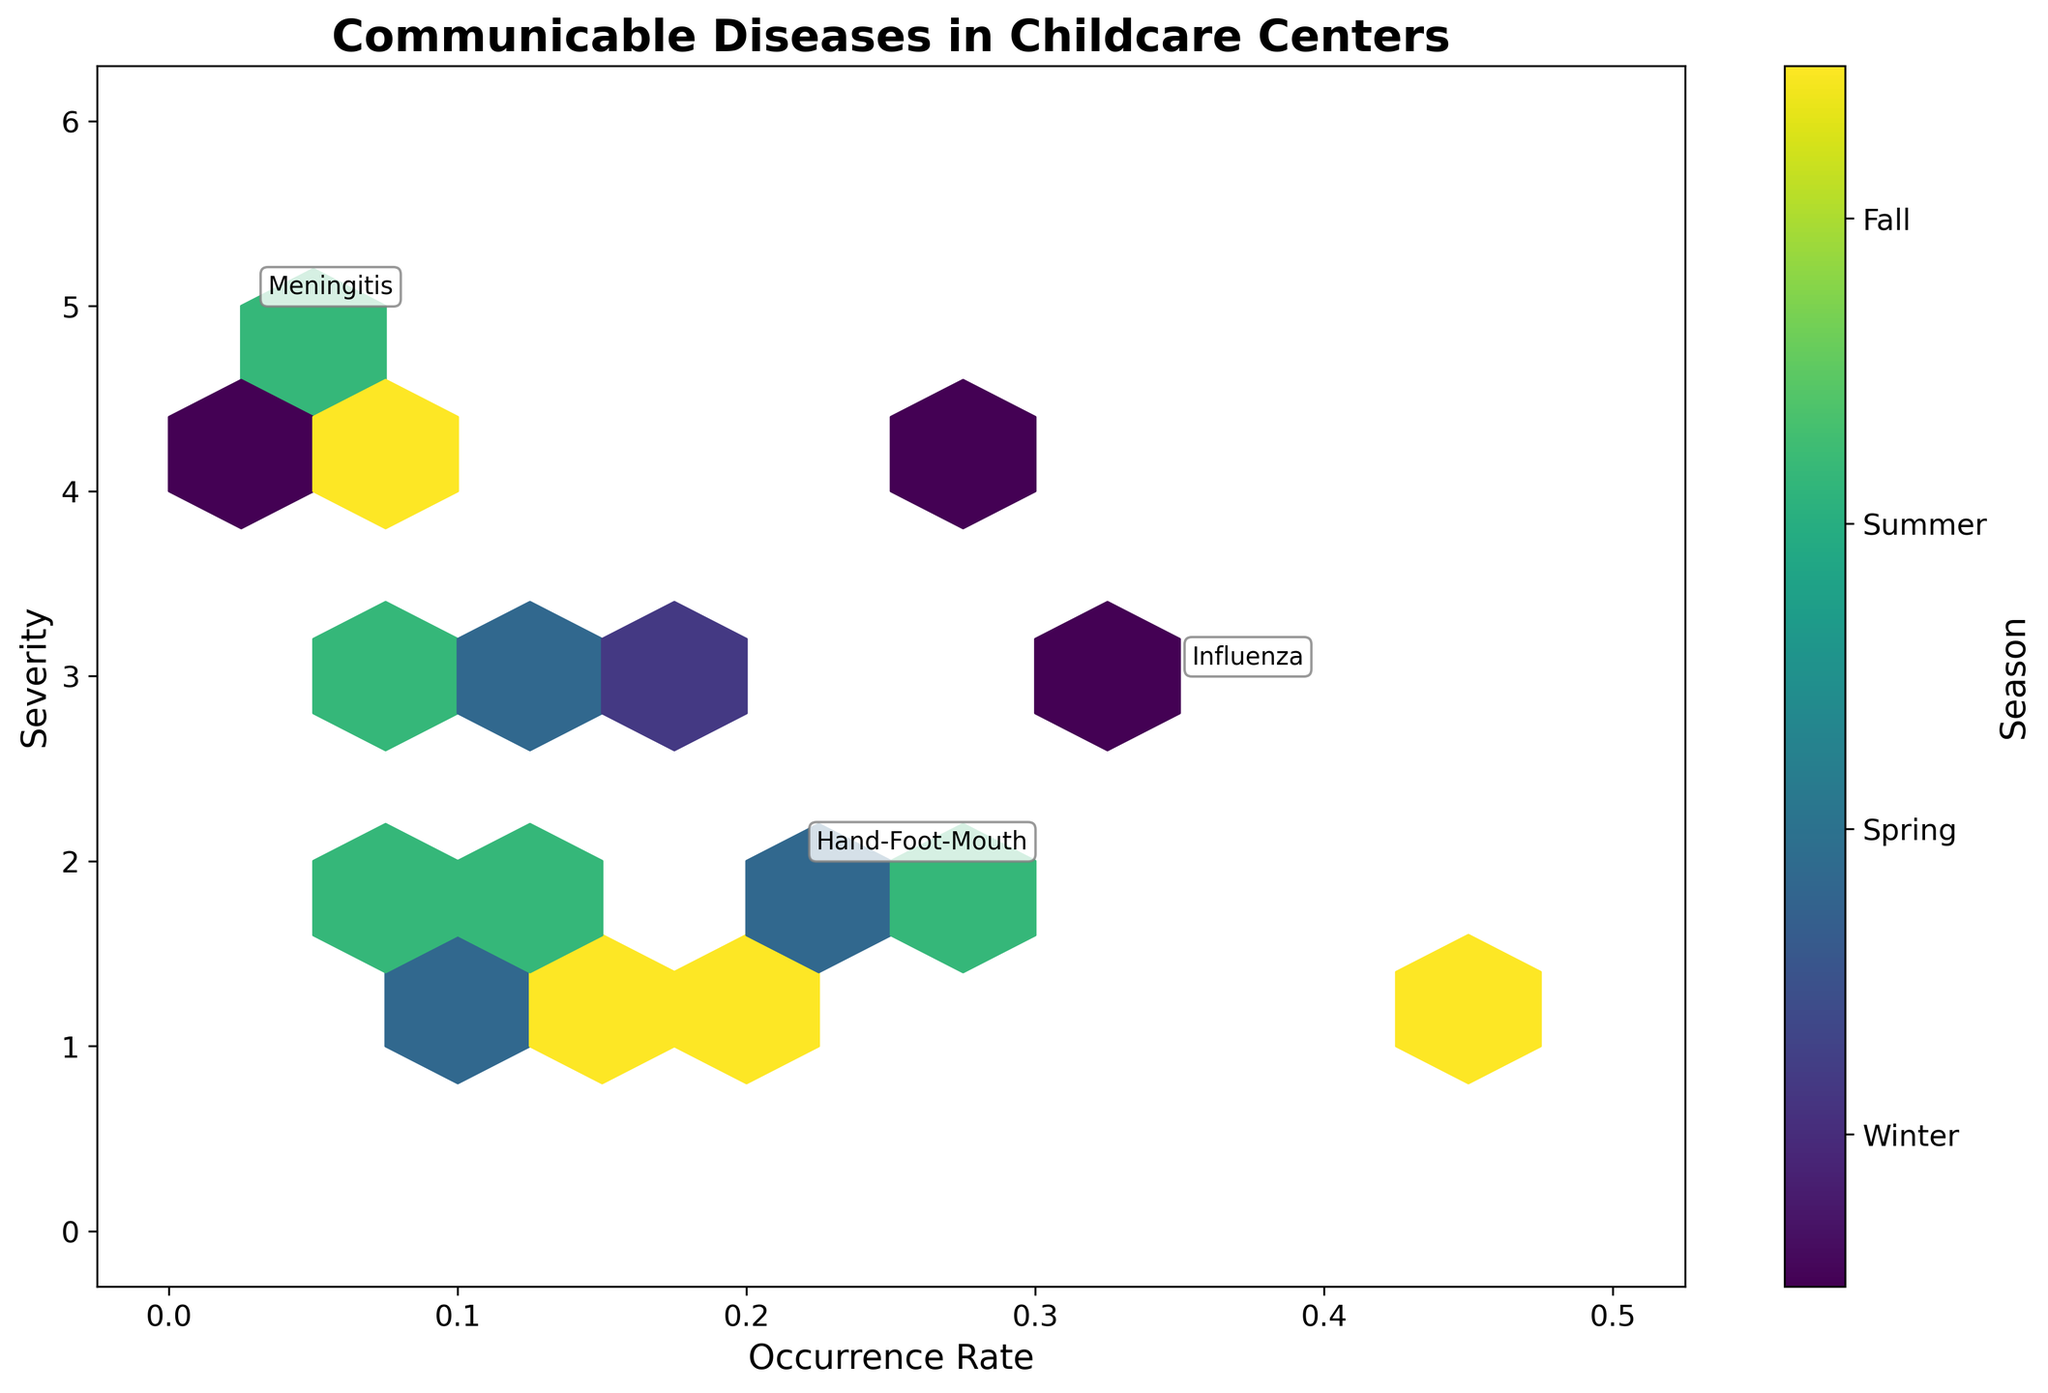What is the title of the hexbin plot? The title is usually found at the top of the plot and provides an overview of the data being displayed. In this case, the title is bold and large, which indicates it is meant to capture attention.
Answer: Communicable Diseases in Childcare Centers What does the x-axis represent? The x-axis is labeled with text that describes the variable being measured along this axis. Here, it indicates a rate of occurrence for different diseases.
Answer: Occurrence Rate Which season has a color label nearest to the top of the color bar? The color bar on the right side of the plot shows the mapping of seasons to colors. By examining the ticks and labels, we see the last label on top.
Answer: Fall How is the severity of diseases visualized in the plot? The y-axis is labeled to indicate what is being measured. In this plot, the y-axis label signifies it's measuring the severity of illnesses.
Answer: By the y-axis values Which diseases are specifically annotated in the plot? Specific diseases are annotated with text on the plot. By looking at these annotations, we can identify the diseases mentioned.
Answer: Influenza, Meningitis, Hand-Foot-Mouth Which season generally has the highest occurrence rate according to the hexbin color scheme? By examining the color intensities and referring to the color bar, we can deduce which season appears most frequently at higher occurrence rates on the x-axis.
Answer: Fall How would you describe the pattern of severe diseases (severity level 4 or 5) in terms of occurrence rates? Severe diseases can be identified along the upper y-axis values (4 or 5). Observing their x-axis positions allows us to determine if they have high or low occurrence rates.
Answer: Low occurrence rates What is the relationship between severity and occurrence rate for diseases in Winter? Comparing the hexbin areas colored for Winter with the positioning on the severity (y-axis) and occurrence (x-axis) provides insights into their relationship.
Answer: Generally, higher severity and medium to high occurrence rates Which annotated disease has the highest severity? By looking at the annotations and checking their corresponding positions on the y-axis, we can identify the disease with the highest severity.
Answer: Meningitis 